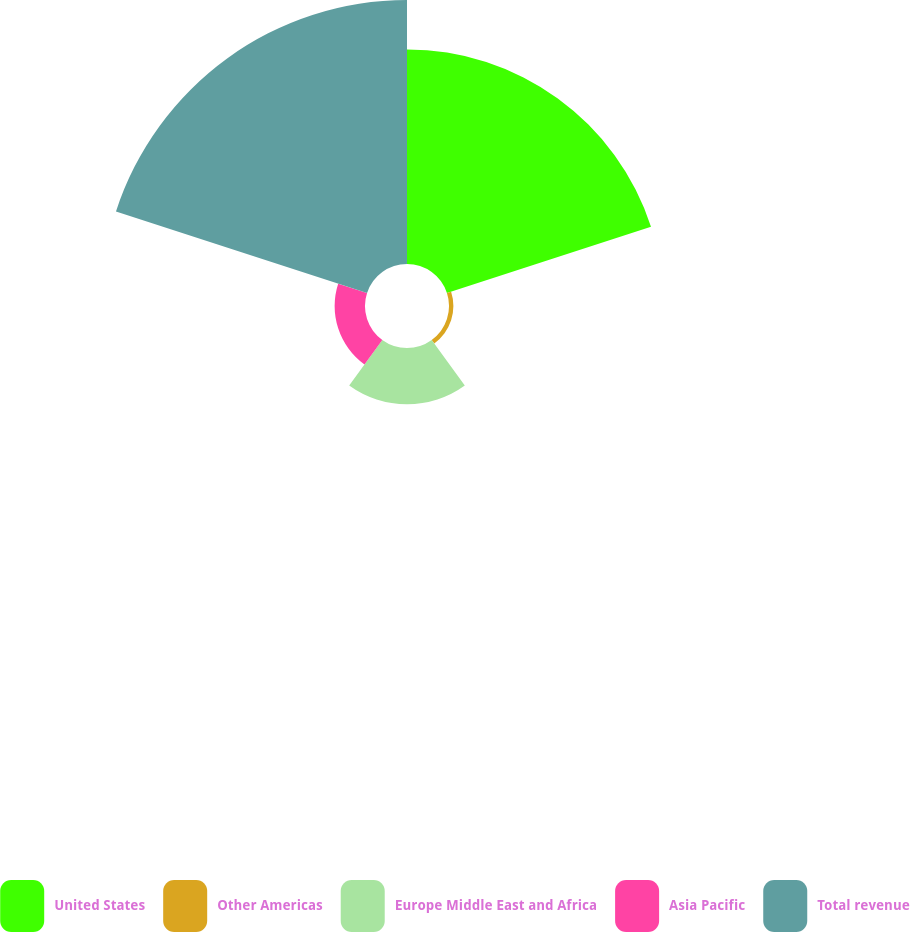<chart> <loc_0><loc_0><loc_500><loc_500><pie_chart><fcel>United States<fcel>Other Americas<fcel>Europe Middle East and Africa<fcel>Asia Pacific<fcel>Total revenue<nl><fcel>37.66%<fcel>0.77%<fcel>9.89%<fcel>5.33%<fcel>46.34%<nl></chart> 